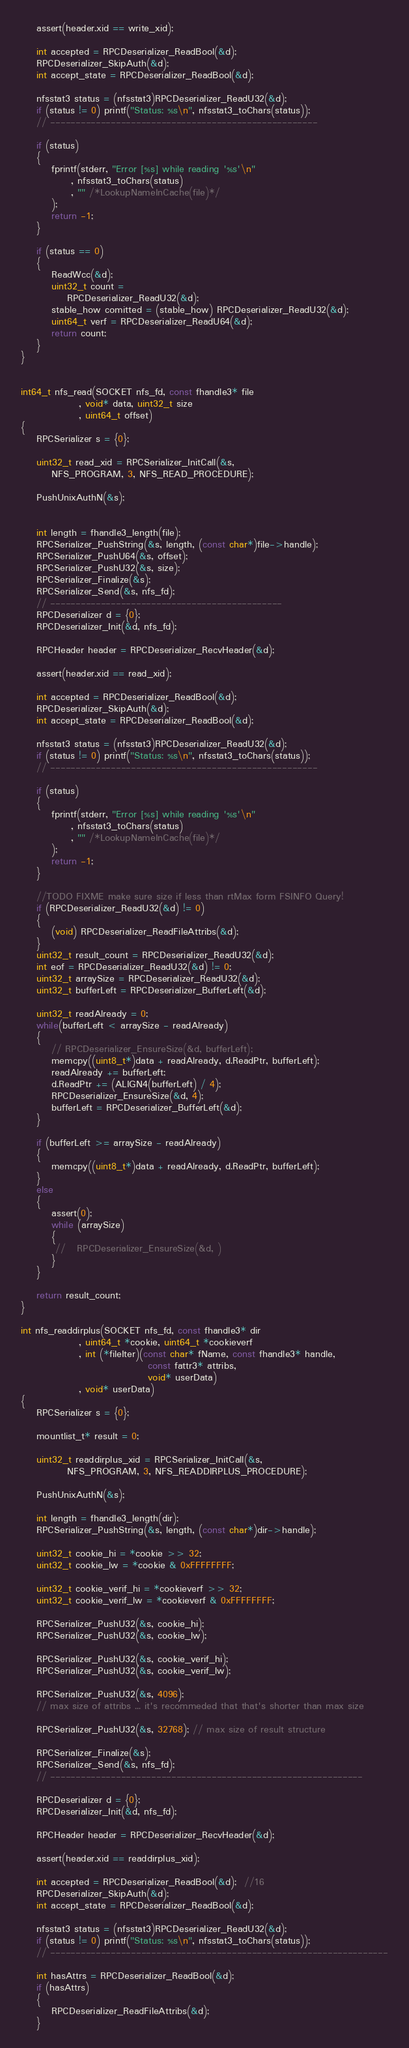<code> <loc_0><loc_0><loc_500><loc_500><_C++_>    assert(header.xid == write_xid);

    int accepted = RPCDeserializer_ReadBool(&d);
    RPCDeserializer_SkipAuth(&d);
    int accept_state = RPCDeserializer_ReadBool(&d);

    nfsstat3 status = (nfsstat3)RPCDeserializer_ReadU32(&d);
    if (status != 0) printf("Status: %s\n", nfsstat3_toChars(status));
    // -----------------------------------------------------

    if (status)
    {
        fprintf(stderr, "Error [%s] while reading '%s'\n"
             , nfsstat3_toChars(status)
             , "" /*LookupNameInCache(file)*/
        );
        return -1;
    }

    if (status == 0)
    {
        ReadWcc(&d);
        uint32_t count =
            RPCDeserializer_ReadU32(&d);
        stable_how comitted = (stable_how) RPCDeserializer_ReadU32(&d);
        uint64_t verf = RPCDeserializer_ReadU64(&d);
        return count;
    }
}


int64_t nfs_read(SOCKET nfs_fd, const fhandle3* file
               , void* data, uint32_t size
               , uint64_t offset)
{
    RPCSerializer s = {0};

    uint32_t read_xid = RPCSerializer_InitCall(&s,
        NFS_PROGRAM, 3, NFS_READ_PROCEDURE);

    PushUnixAuthN(&s);


    int length = fhandle3_length(file);
    RPCSerializer_PushString(&s, length, (const char*)file->handle);
    RPCSerializer_PushU64(&s, offset);
    RPCSerializer_PushU32(&s, size);
    RPCSerializer_Finalize(&s);
    RPCSerializer_Send(&s, nfs_fd);
    // ----------------------------------------------
    RPCDeserializer d = {0};
    RPCDeserializer_Init(&d, nfs_fd);

    RPCHeader header = RPCDeserializer_RecvHeader(&d);

    assert(header.xid == read_xid);

    int accepted = RPCDeserializer_ReadBool(&d);
    RPCDeserializer_SkipAuth(&d);
    int accept_state = RPCDeserializer_ReadBool(&d);

    nfsstat3 status = (nfsstat3)RPCDeserializer_ReadU32(&d);
    if (status != 0) printf("Status: %s\n", nfsstat3_toChars(status));
    // -----------------------------------------------------

    if (status)
    {
        fprintf(stderr, "Error [%s] while reading '%s'\n"
             , nfsstat3_toChars(status)
             , "" /*LookupNameInCache(file)*/
        );
        return -1;
    }

    //TODO FIXME make sure size if less than rtMax form FSINFO Query!
    if (RPCDeserializer_ReadU32(&d) != 0)
    {
        (void) RPCDeserializer_ReadFileAttribs(&d);
    }
    uint32_t result_count = RPCDeserializer_ReadU32(&d);
    int eof = RPCDeserializer_ReadU32(&d) != 0;
    uint32_t arraySize = RPCDeserializer_ReadU32(&d);
    uint32_t bufferLeft = RPCDeserializer_BufferLeft(&d);

    uint32_t readAlready = 0;
    while(bufferLeft < arraySize - readAlready)
    {
        // RPCDeserializer_EnsureSize(&d, bufferLeft);
        memcpy((uint8_t*)data + readAlready, d.ReadPtr, bufferLeft);
        readAlready += bufferLeft;
        d.ReadPtr += (ALIGN4(bufferLeft) / 4);
        RPCDeserializer_EnsureSize(&d, 4);
        bufferLeft = RPCDeserializer_BufferLeft(&d);
    }

    if (bufferLeft >= arraySize - readAlready)
    {
        memcpy((uint8_t*)data + readAlready, d.ReadPtr, bufferLeft);
    }
    else
    {
        assert(0);
        while (arraySize)
        {
         //   RPCDeserializer_EnsureSize(&d, )
        }
    }

    return result_count;
}

int nfs_readdirplus(SOCKET nfs_fd, const fhandle3* dir
               , uint64_t *cookie, uint64_t *cookieverf
               , int (*fileIter)(const char* fName, const fhandle3* handle,
                                 const fattr3* attribs,
                                 void* userData)
               , void* userData)
{
    RPCSerializer s = {0};

    mountlist_t* result = 0;

    uint32_t readdirplus_xid = RPCSerializer_InitCall(&s,
            NFS_PROGRAM, 3, NFS_READDIRPLUS_PROCEDURE);

    PushUnixAuthN(&s);

    int length = fhandle3_length(dir);
    RPCSerializer_PushString(&s, length, (const char*)dir->handle);

    uint32_t cookie_hi = *cookie >> 32;
    uint32_t cookie_lw = *cookie & 0xFFFFFFFF;

    uint32_t cookie_verif_hi = *cookieverf >> 32;
    uint32_t cookie_verif_lw = *cookieverf & 0xFFFFFFFF;

    RPCSerializer_PushU32(&s, cookie_hi);
    RPCSerializer_PushU32(&s, cookie_lw);

    RPCSerializer_PushU32(&s, cookie_verif_hi);
    RPCSerializer_PushU32(&s, cookie_verif_lw);

    RPCSerializer_PushU32(&s, 4096);
    // max size of attribs ... it's recommeded that that's shorter than max size

    RPCSerializer_PushU32(&s, 32768); // max size of result structure

    RPCSerializer_Finalize(&s);
    RPCSerializer_Send(&s, nfs_fd);
    // --------------------------------------------------------------

    RPCDeserializer d = {0};
    RPCDeserializer_Init(&d, nfs_fd);

    RPCHeader header = RPCDeserializer_RecvHeader(&d);

    assert(header.xid == readdirplus_xid);

    int accepted = RPCDeserializer_ReadBool(&d);  //16
    RPCDeserializer_SkipAuth(&d);
    int accept_state = RPCDeserializer_ReadBool(&d);

    nfsstat3 status = (nfsstat3)RPCDeserializer_ReadU32(&d);
    if (status != 0) printf("Status: %s\n", nfsstat3_toChars(status));
    // -------------------------------------------------------------------

    int hasAttrs = RPCDeserializer_ReadBool(&d);
    if (hasAttrs)
    {
        RPCDeserializer_ReadFileAttribs(&d);
    }
</code> 